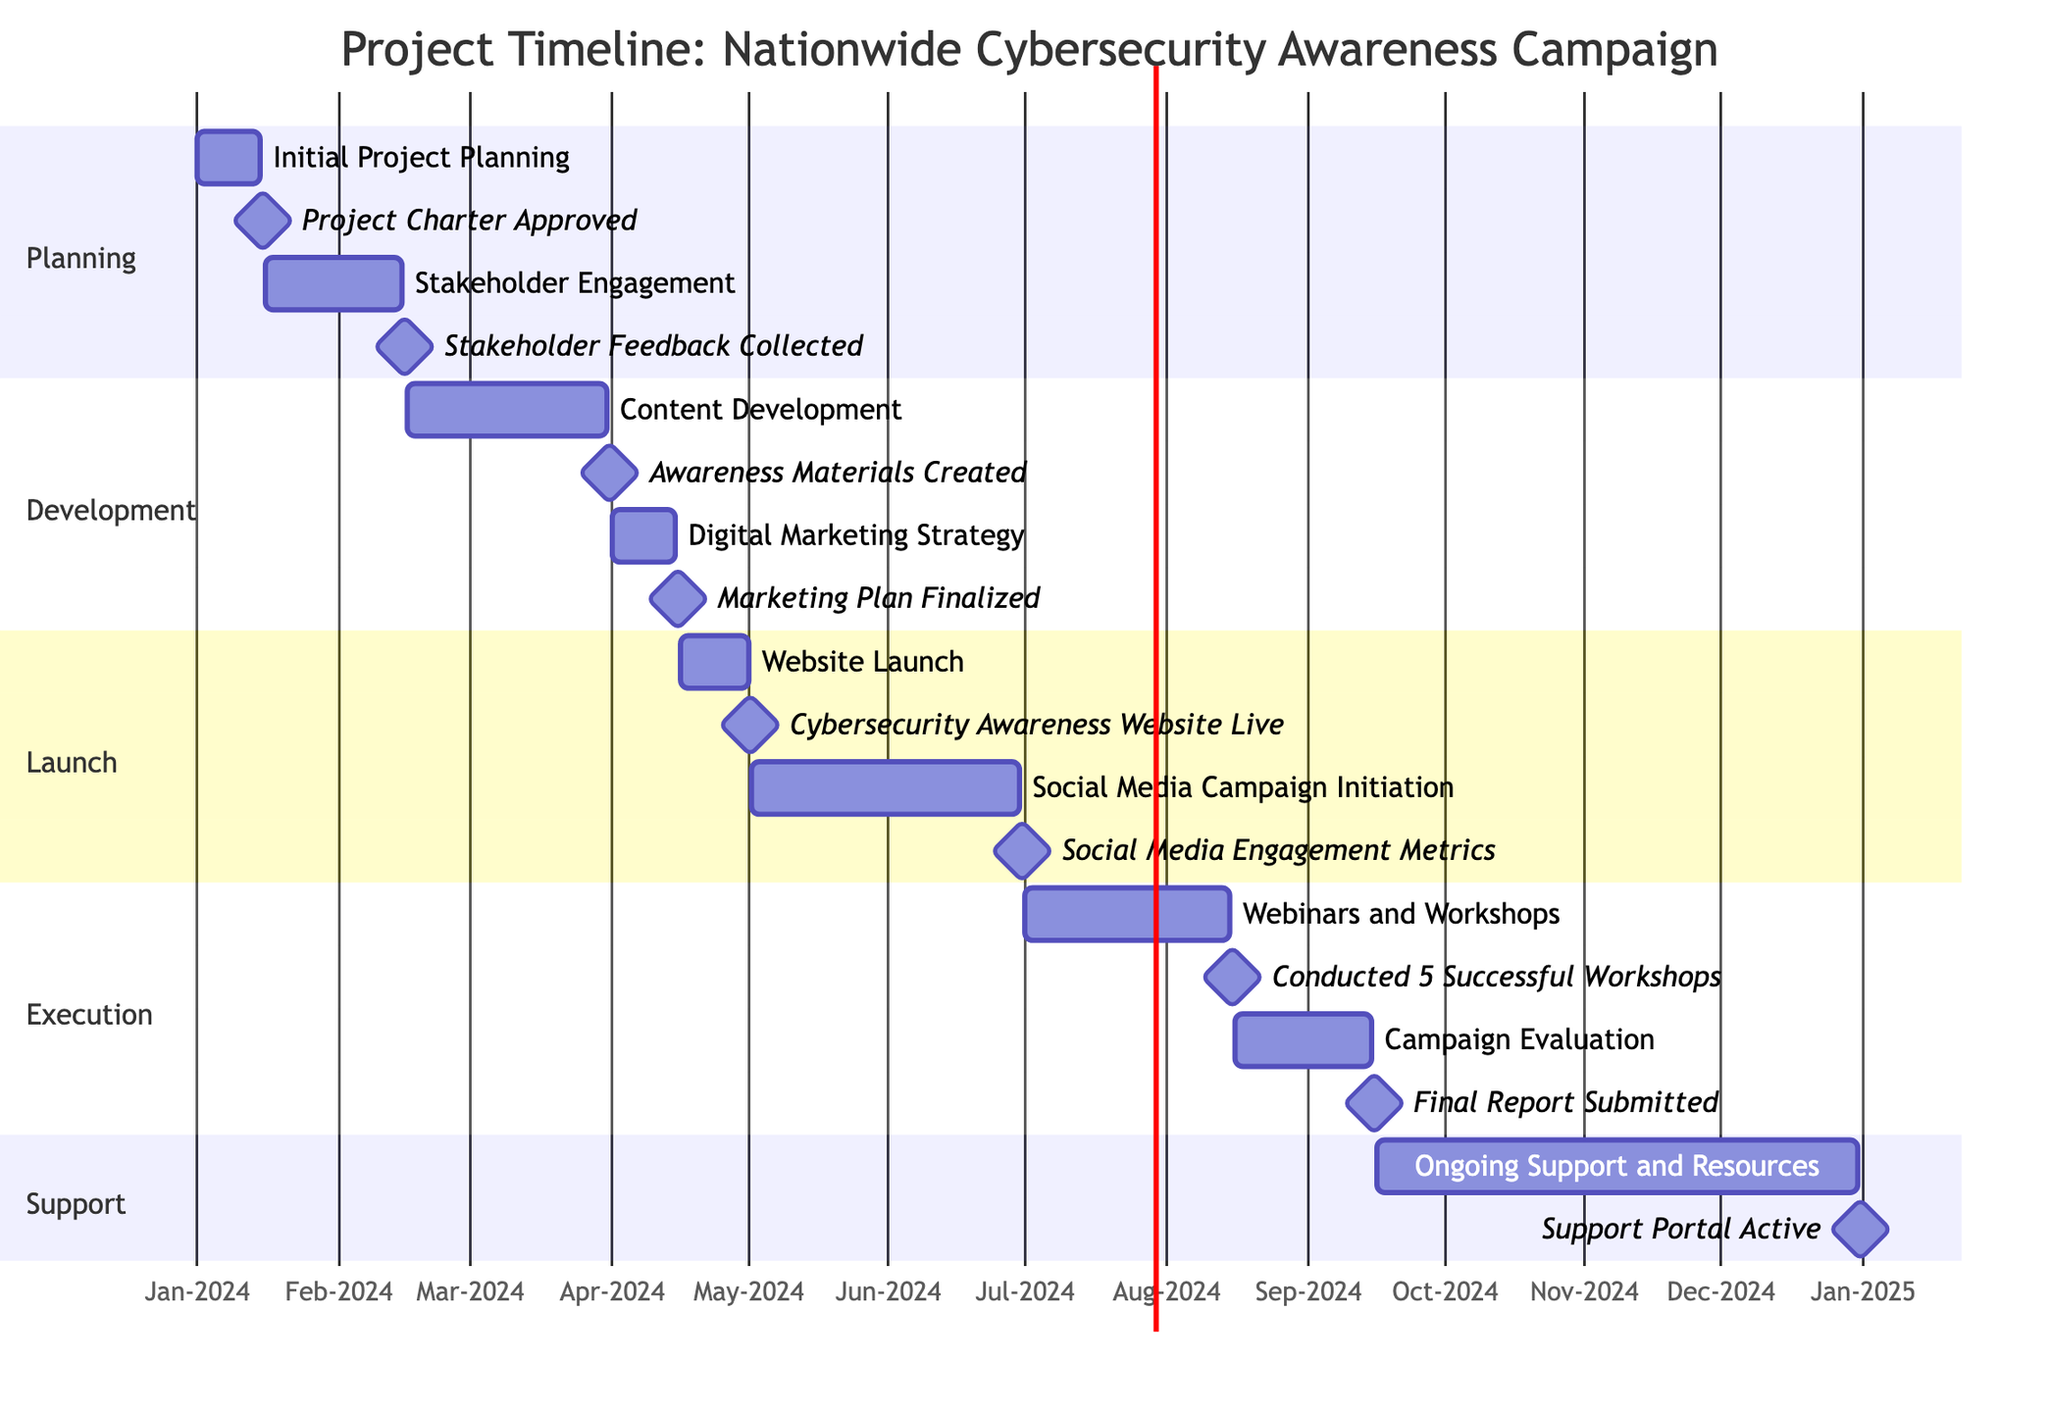What is the duration of the "Content Development" activity? The "Content Development" activity starts on February 16, 2024, and ends on March 31, 2024. To calculate the duration, count the number of days between these two dates, which is 44 days.
Answer: 44 days What milestone is associated with "Stakeholder Engagement"? "Stakeholder Engagement" ends on February 15, 2024, and the associated milestone is "Stakeholder Feedback Collected," which occurs on that same date.
Answer: Stakeholder Feedback Collected Which activity follows the "Website Launch" in the timeline? "Website Launch" ends on May 1, 2024. The next activity that starts immediately after is "Social Media Campaign Initiation," which begins on May 2, 2024.
Answer: Social Media Campaign Initiation How many activities are planned before the "Campaign Evaluation"? Reviewing the timeline, we see the activities listed before "Campaign Evaluation," which starts on August 16, are "Initial Project Planning," "Stakeholder Engagement," "Content Development," "Digital Marketing Strategy," "Website Launch," and "Social Media Campaign Initiation," totaling six activities.
Answer: 6 activities What is the end date of the "Ongoing Support and Resources" activity? The "Ongoing Support and Resources" activity starts on September 16, 2024, and lasts until December 31, 2024. The end date of this activity is thus December 31, 2024.
Answer: December 31, 2024 Which section includes the "Digital Marketing Strategy" activity? The "Digital Marketing Strategy" activity is included under the "Development" section of the Gantt Chart.
Answer: Development What is the total number of milestones in this project timeline? The project timeline includes milestones after each main activity, totaling to 8 milestones throughout the timeline.
Answer: 8 milestones What activity is scheduled right before "Webinars and Workshops"? The activity scheduled right before "Webinars and Workshops" is "Social Media Campaign Initiation," which ends on June 30, 2024, just prior to the start of the webinars on July 1, 2024.
Answer: Social Media Campaign Initiation Which activity spans the longest duration? To determine the longest duration, we compare each activity's start and end dates; "Ongoing Support and Resources," running from September 16, 2024, to December 31, 2024, spans the longest duration of 106 days.
Answer: Ongoing Support and Resources 